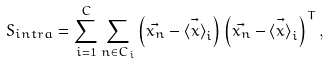<formula> <loc_0><loc_0><loc_500><loc_500>S _ { i n t r a } = \sum _ { i = 1 } ^ { C } \sum _ { n \in C _ { i } } \left ( \vec { x _ { n } } - \vec { \left < x \right > } _ { i } \right ) \left ( \vec { x _ { n } } - \vec { \left < x \right > } _ { i } \right ) ^ { T } ,</formula> 